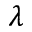Convert formula to latex. <formula><loc_0><loc_0><loc_500><loc_500>\lambda</formula> 